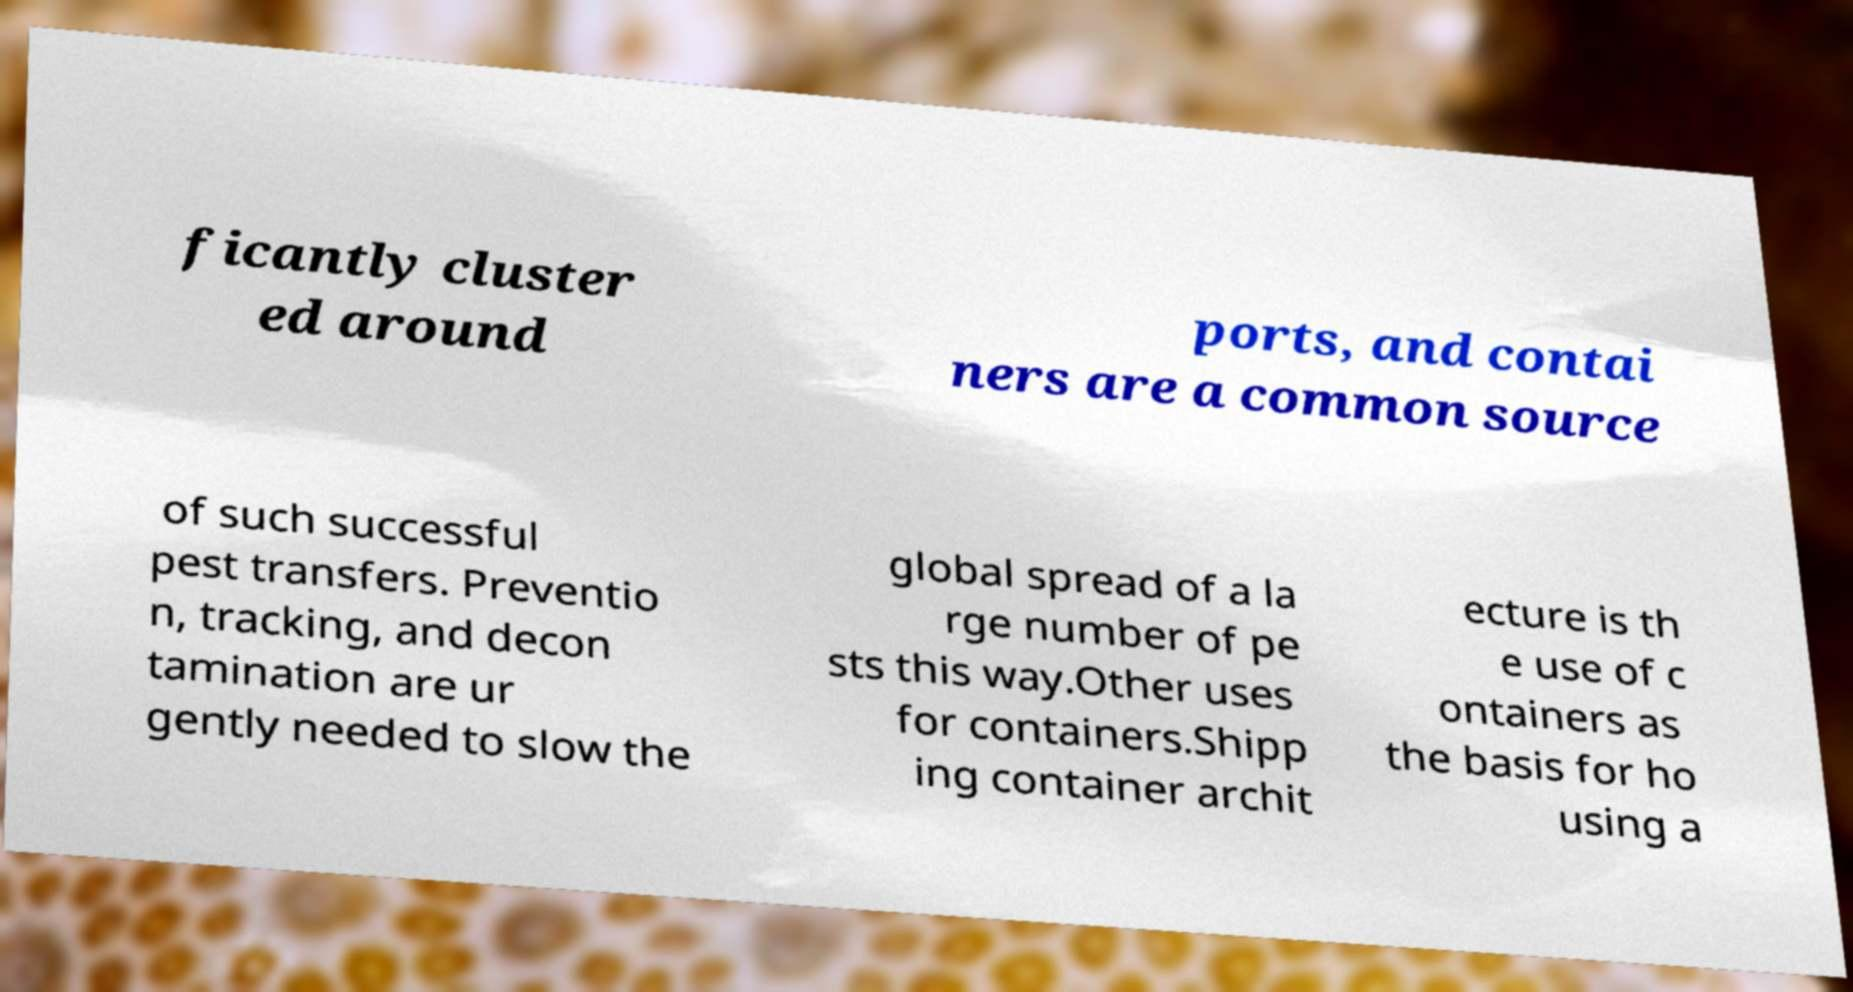I need the written content from this picture converted into text. Can you do that? ficantly cluster ed around ports, and contai ners are a common source of such successful pest transfers. Preventio n, tracking, and decon tamination are ur gently needed to slow the global spread of a la rge number of pe sts this way.Other uses for containers.Shipp ing container archit ecture is th e use of c ontainers as the basis for ho using a 